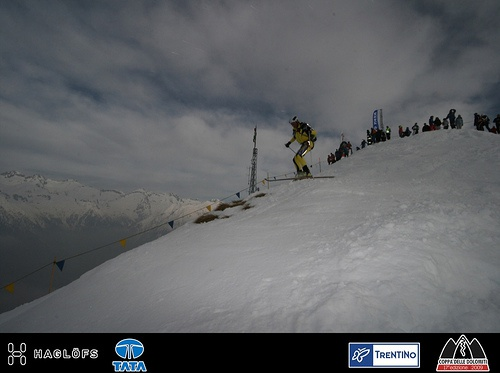Describe the objects in this image and their specific colors. I can see people in darkblue, black, and gray tones, people in darkblue, black, olive, and gray tones, people in black, gray, and darkblue tones, people in darkblue, black, and gray tones, and skis in darkblue, black, and gray tones in this image. 